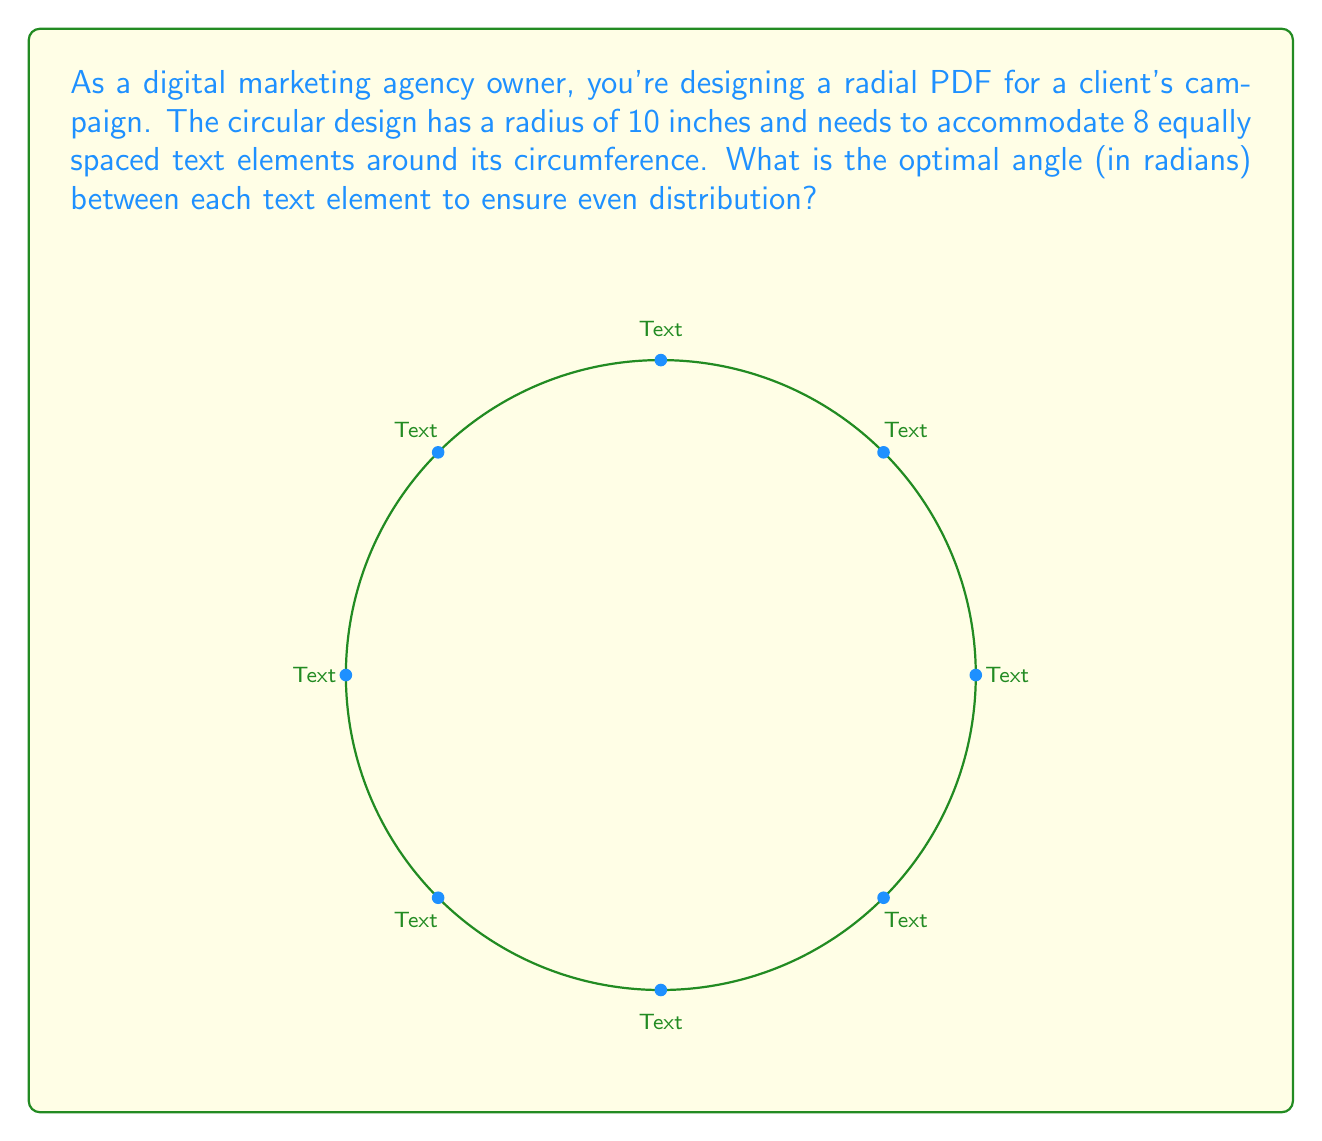Could you help me with this problem? To determine the optimal angle for evenly spacing 8 text elements around a circle, we can follow these steps:

1. Recall that a full circle contains $2\pi$ radians or 360°.

2. Since we need to divide the circle into 8 equal parts, we can calculate the angle between each text element as follows:

   $$\text{Angle} = \frac{\text{Total angle of the circle}}{\text{Number of text elements}}$$

3. Substituting the values:

   $$\text{Angle} = \frac{2\pi}{8}$$

4. Simplify:

   $$\text{Angle} = \frac{\pi}{4} \text{ radians}$$

5. This angle ensures that the text elements are evenly distributed around the circumference of the circular PDF design, optimizing readability and visual appeal for the marketing campaign.

Note: While the radius of 10 inches is given in the question, it doesn't affect the calculation of the angle between text elements. The angle remains constant regardless of the circle's size.
Answer: $\frac{\pi}{4}$ radians 